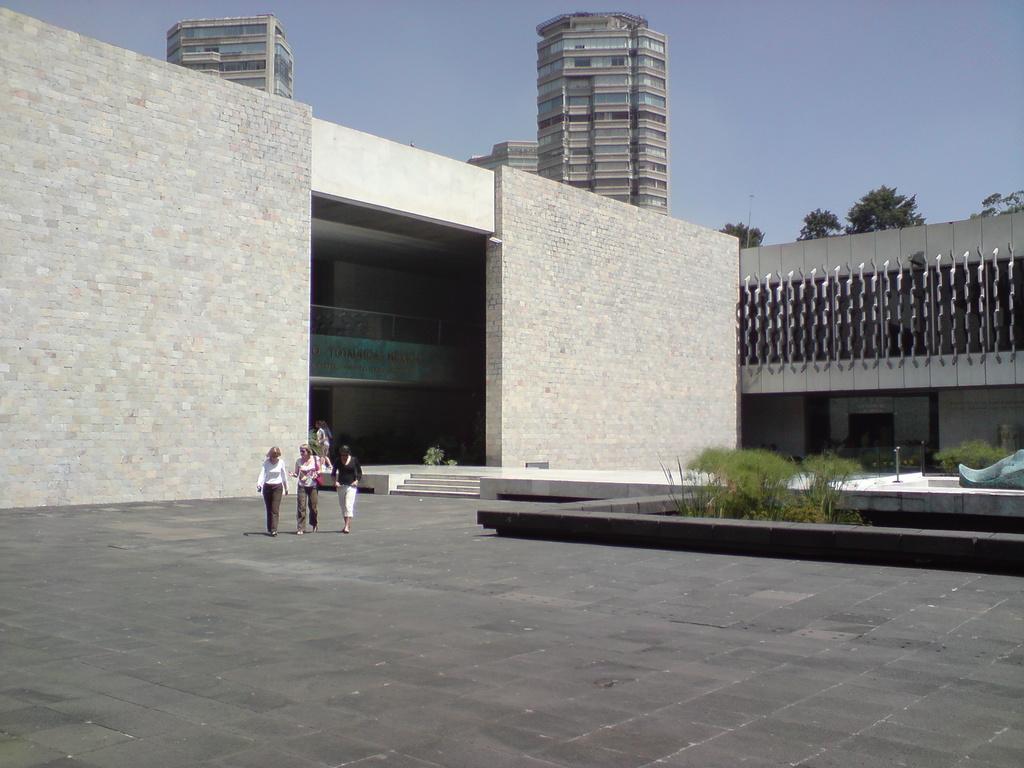Can you describe this image briefly? There are people walking. We can see plants, sculpture and steps. In the background we can see people, building, trees and sky. 